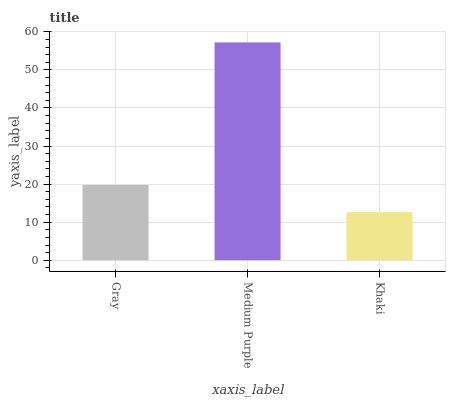Is Khaki the minimum?
Answer yes or no. Yes. Is Medium Purple the maximum?
Answer yes or no. Yes. Is Medium Purple the minimum?
Answer yes or no. No. Is Khaki the maximum?
Answer yes or no. No. Is Medium Purple greater than Khaki?
Answer yes or no. Yes. Is Khaki less than Medium Purple?
Answer yes or no. Yes. Is Khaki greater than Medium Purple?
Answer yes or no. No. Is Medium Purple less than Khaki?
Answer yes or no. No. Is Gray the high median?
Answer yes or no. Yes. Is Gray the low median?
Answer yes or no. Yes. Is Khaki the high median?
Answer yes or no. No. Is Khaki the low median?
Answer yes or no. No. 